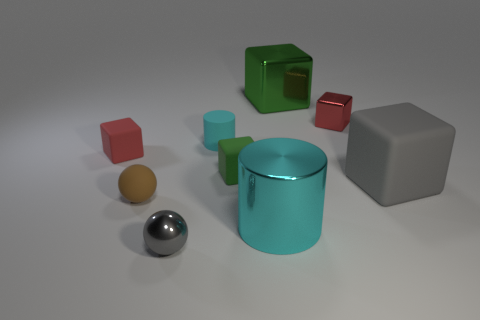Subtract all tiny metal blocks. How many blocks are left? 4 Add 1 tiny purple spheres. How many objects exist? 10 Subtract all brown cylinders. How many red cubes are left? 2 Subtract all blocks. How many objects are left? 4 Subtract all red cubes. How many cubes are left? 3 Add 5 small shiny things. How many small shiny things are left? 7 Add 3 tiny brown metallic objects. How many tiny brown metallic objects exist? 3 Subtract 0 green cylinders. How many objects are left? 9 Subtract 1 spheres. How many spheres are left? 1 Subtract all red spheres. Subtract all purple blocks. How many spheres are left? 2 